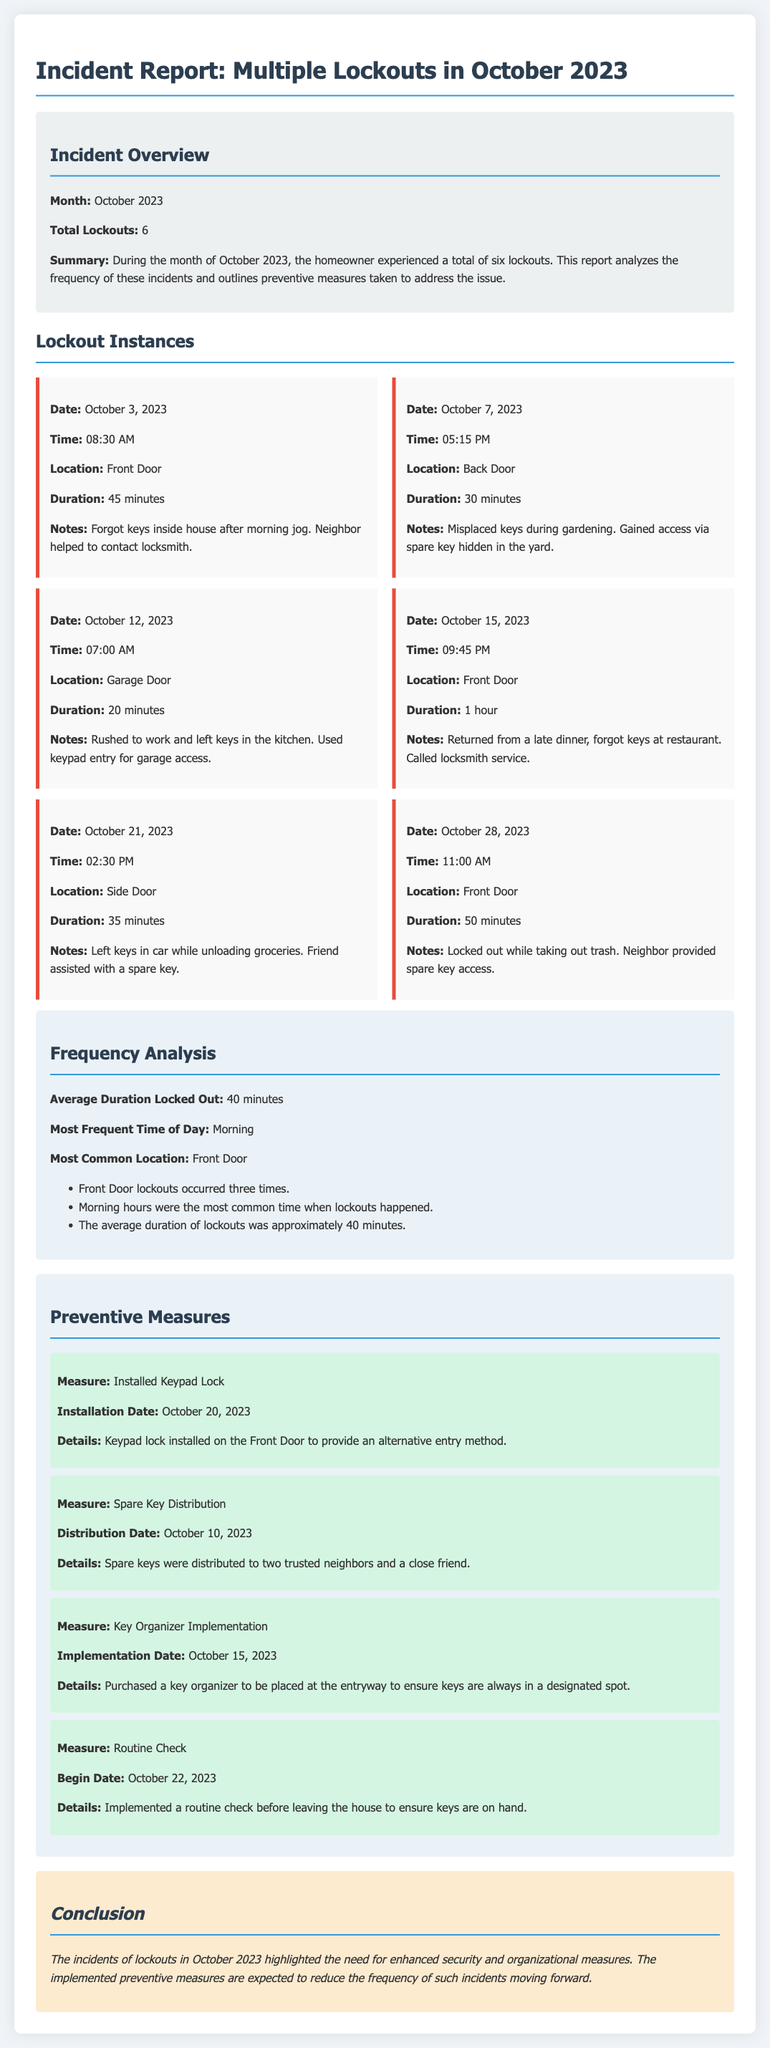What is the total number of lockouts? The document states that there were a total of six lockouts during October 2023.
Answer: 6 What was the most common location for lockouts? According to the analysis, the most common location for lockouts was the Front Door, which occurred three times.
Answer: Front Door When was the keypad lock installed? The preventive measures section specifies that the keypad lock was installed on October 20, 2023.
Answer: October 20, 2023 What was the average duration of lockouts? The document indicates that the average duration of lockouts was approximately 40 minutes.
Answer: 40 minutes How many times did lockouts occur in the morning? Based on the frequency analysis, morning hours were noted as the most common time for lockouts, indicating multiple instances.
Answer: Multiple times What preventive measure was taken on October 15, 2023? The key organizer was implemented on October 15, 2023, to help keep track of keys.
Answer: Key Organizer Implementation What did the homeowner forget on October 3, 2023? The notes from the first incident report that the homeowner forgot keys inside the house after a morning jog.
Answer: Keys inside house What assistance did the homeowner receive on October 21, 2023? The homeowner received assistance from a friend who helped with a spare key after leaving keys in the car.
Answer: Friend assisted with a spare key What measure began on October 22, 2023? The document mentions that a routine check was implemented to ensure keys are on hand starting from October 22, 2023.
Answer: Routine Check 